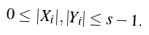<formula> <loc_0><loc_0><loc_500><loc_500>0 \leq | X _ { i } | , | Y _ { i } | \leq s - 1 .</formula> 